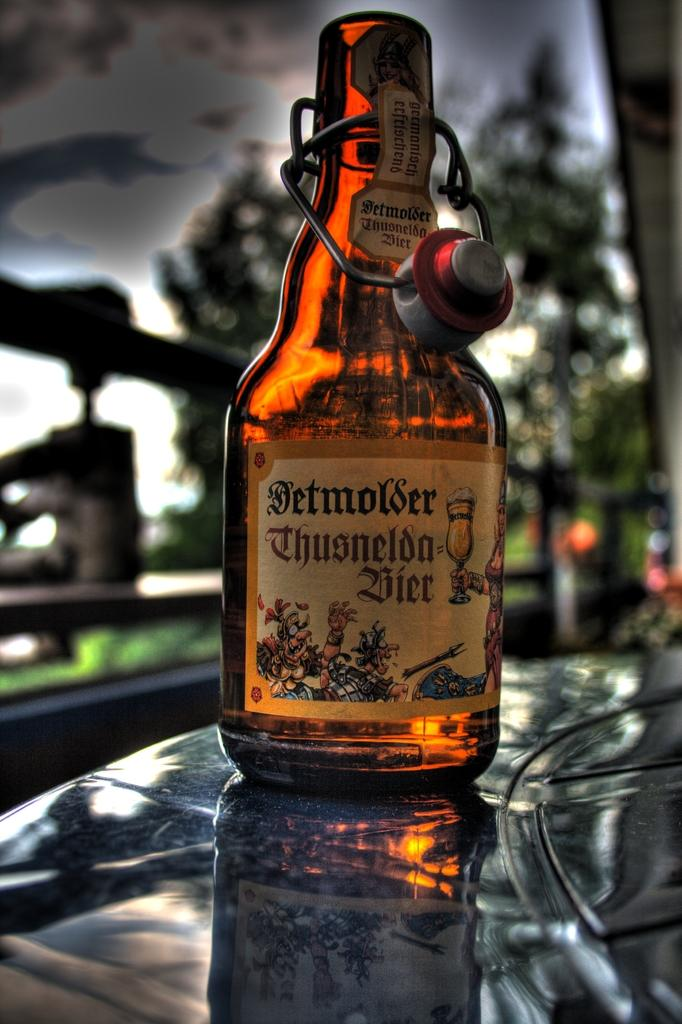What is the condition of the wine bottle in the image? The wine bottle has an open cap in the image. Where is the wine bottle placed? The wine bottle is placed on a hood in the image. What can be seen in the background of the image? There are trees in the background of the image. What is the weather like in the image? The sky is covered with dark clouds in the image, suggesting a potentially stormy or overcast weather. What architectural feature is present in the image? There is a fence in the image. What date is marked on the calendar in the image? There is no calendar present in the image, so it is not possible to determine the date. 